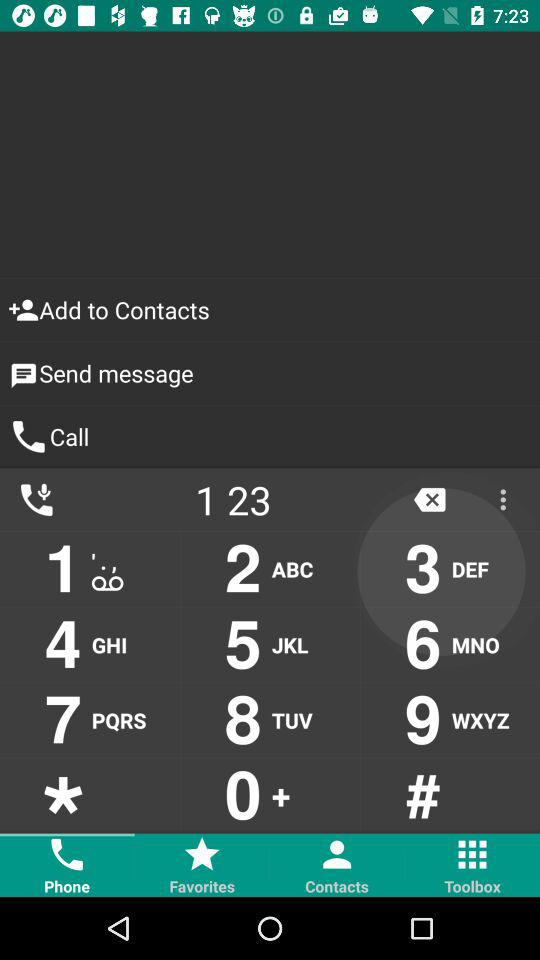Which tab is selected? The selected tab is "Phone". 